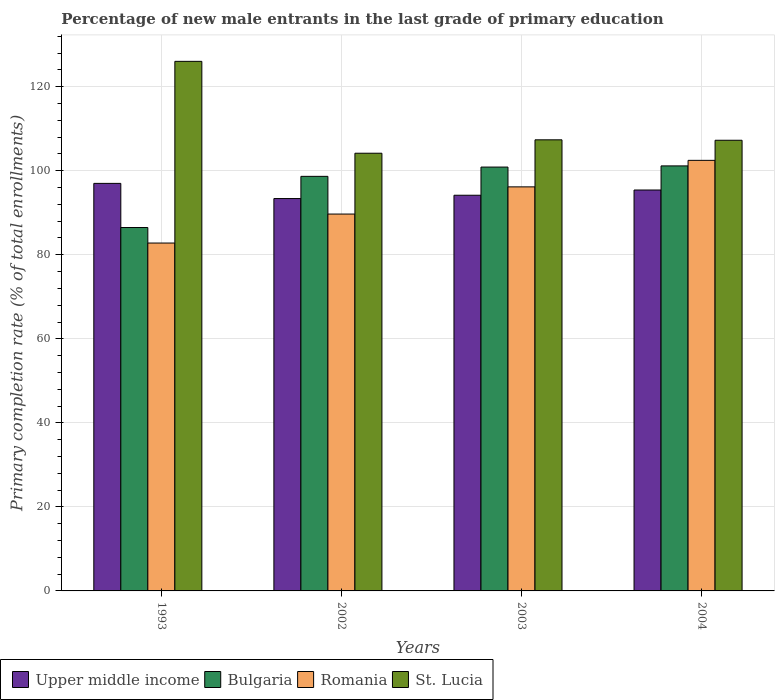How many different coloured bars are there?
Keep it short and to the point. 4. How many groups of bars are there?
Offer a terse response. 4. What is the label of the 2nd group of bars from the left?
Provide a succinct answer. 2002. What is the percentage of new male entrants in Bulgaria in 2003?
Offer a terse response. 100.88. Across all years, what is the maximum percentage of new male entrants in St. Lucia?
Give a very brief answer. 126.04. Across all years, what is the minimum percentage of new male entrants in Bulgaria?
Provide a succinct answer. 86.49. In which year was the percentage of new male entrants in Romania minimum?
Give a very brief answer. 1993. What is the total percentage of new male entrants in St. Lucia in the graph?
Your response must be concise. 444.83. What is the difference between the percentage of new male entrants in Bulgaria in 2002 and that in 2003?
Make the answer very short. -2.21. What is the difference between the percentage of new male entrants in Bulgaria in 1993 and the percentage of new male entrants in Romania in 2002?
Offer a terse response. -3.21. What is the average percentage of new male entrants in St. Lucia per year?
Make the answer very short. 111.21. In the year 2003, what is the difference between the percentage of new male entrants in Bulgaria and percentage of new male entrants in Romania?
Offer a very short reply. 4.71. In how many years, is the percentage of new male entrants in Upper middle income greater than 56 %?
Your answer should be compact. 4. What is the ratio of the percentage of new male entrants in Bulgaria in 2003 to that in 2004?
Ensure brevity in your answer.  1. Is the difference between the percentage of new male entrants in Bulgaria in 1993 and 2004 greater than the difference between the percentage of new male entrants in Romania in 1993 and 2004?
Provide a short and direct response. Yes. What is the difference between the highest and the second highest percentage of new male entrants in Bulgaria?
Offer a terse response. 0.28. What is the difference between the highest and the lowest percentage of new male entrants in Romania?
Provide a succinct answer. 19.68. Is the sum of the percentage of new male entrants in Romania in 1993 and 2004 greater than the maximum percentage of new male entrants in Upper middle income across all years?
Provide a succinct answer. Yes. Is it the case that in every year, the sum of the percentage of new male entrants in St. Lucia and percentage of new male entrants in Bulgaria is greater than the sum of percentage of new male entrants in Upper middle income and percentage of new male entrants in Romania?
Make the answer very short. Yes. What does the 4th bar from the left in 2002 represents?
Offer a terse response. St. Lucia. What does the 1st bar from the right in 2003 represents?
Your answer should be compact. St. Lucia. Are all the bars in the graph horizontal?
Provide a succinct answer. No. How many years are there in the graph?
Provide a short and direct response. 4. What is the difference between two consecutive major ticks on the Y-axis?
Offer a very short reply. 20. Are the values on the major ticks of Y-axis written in scientific E-notation?
Give a very brief answer. No. Does the graph contain any zero values?
Your answer should be compact. No. How are the legend labels stacked?
Your response must be concise. Horizontal. What is the title of the graph?
Your answer should be very brief. Percentage of new male entrants in the last grade of primary education. Does "Ethiopia" appear as one of the legend labels in the graph?
Your response must be concise. No. What is the label or title of the Y-axis?
Make the answer very short. Primary completion rate (% of total enrollments). What is the Primary completion rate (% of total enrollments) of Upper middle income in 1993?
Keep it short and to the point. 96.99. What is the Primary completion rate (% of total enrollments) in Bulgaria in 1993?
Offer a terse response. 86.49. What is the Primary completion rate (% of total enrollments) in Romania in 1993?
Offer a very short reply. 82.8. What is the Primary completion rate (% of total enrollments) in St. Lucia in 1993?
Give a very brief answer. 126.04. What is the Primary completion rate (% of total enrollments) in Upper middle income in 2002?
Your answer should be compact. 93.38. What is the Primary completion rate (% of total enrollments) of Bulgaria in 2002?
Make the answer very short. 98.67. What is the Primary completion rate (% of total enrollments) of Romania in 2002?
Ensure brevity in your answer.  89.69. What is the Primary completion rate (% of total enrollments) in St. Lucia in 2002?
Make the answer very short. 104.17. What is the Primary completion rate (% of total enrollments) of Upper middle income in 2003?
Give a very brief answer. 94.17. What is the Primary completion rate (% of total enrollments) of Bulgaria in 2003?
Keep it short and to the point. 100.88. What is the Primary completion rate (% of total enrollments) in Romania in 2003?
Give a very brief answer. 96.16. What is the Primary completion rate (% of total enrollments) in St. Lucia in 2003?
Offer a terse response. 107.36. What is the Primary completion rate (% of total enrollments) of Upper middle income in 2004?
Your answer should be compact. 95.42. What is the Primary completion rate (% of total enrollments) in Bulgaria in 2004?
Offer a terse response. 101.16. What is the Primary completion rate (% of total enrollments) of Romania in 2004?
Make the answer very short. 102.48. What is the Primary completion rate (% of total enrollments) in St. Lucia in 2004?
Your response must be concise. 107.26. Across all years, what is the maximum Primary completion rate (% of total enrollments) of Upper middle income?
Make the answer very short. 96.99. Across all years, what is the maximum Primary completion rate (% of total enrollments) of Bulgaria?
Offer a very short reply. 101.16. Across all years, what is the maximum Primary completion rate (% of total enrollments) of Romania?
Provide a succinct answer. 102.48. Across all years, what is the maximum Primary completion rate (% of total enrollments) of St. Lucia?
Your answer should be compact. 126.04. Across all years, what is the minimum Primary completion rate (% of total enrollments) in Upper middle income?
Your answer should be compact. 93.38. Across all years, what is the minimum Primary completion rate (% of total enrollments) in Bulgaria?
Keep it short and to the point. 86.49. Across all years, what is the minimum Primary completion rate (% of total enrollments) of Romania?
Give a very brief answer. 82.8. Across all years, what is the minimum Primary completion rate (% of total enrollments) in St. Lucia?
Give a very brief answer. 104.17. What is the total Primary completion rate (% of total enrollments) in Upper middle income in the graph?
Your answer should be very brief. 379.97. What is the total Primary completion rate (% of total enrollments) in Bulgaria in the graph?
Offer a terse response. 387.19. What is the total Primary completion rate (% of total enrollments) of Romania in the graph?
Ensure brevity in your answer.  371.13. What is the total Primary completion rate (% of total enrollments) in St. Lucia in the graph?
Your answer should be very brief. 444.83. What is the difference between the Primary completion rate (% of total enrollments) in Upper middle income in 1993 and that in 2002?
Provide a short and direct response. 3.61. What is the difference between the Primary completion rate (% of total enrollments) of Bulgaria in 1993 and that in 2002?
Your answer should be very brief. -12.18. What is the difference between the Primary completion rate (% of total enrollments) of Romania in 1993 and that in 2002?
Offer a terse response. -6.9. What is the difference between the Primary completion rate (% of total enrollments) in St. Lucia in 1993 and that in 2002?
Make the answer very short. 21.86. What is the difference between the Primary completion rate (% of total enrollments) of Upper middle income in 1993 and that in 2003?
Provide a short and direct response. 2.82. What is the difference between the Primary completion rate (% of total enrollments) in Bulgaria in 1993 and that in 2003?
Your response must be concise. -14.39. What is the difference between the Primary completion rate (% of total enrollments) in Romania in 1993 and that in 2003?
Provide a succinct answer. -13.37. What is the difference between the Primary completion rate (% of total enrollments) of St. Lucia in 1993 and that in 2003?
Provide a succinct answer. 18.68. What is the difference between the Primary completion rate (% of total enrollments) of Upper middle income in 1993 and that in 2004?
Offer a very short reply. 1.57. What is the difference between the Primary completion rate (% of total enrollments) of Bulgaria in 1993 and that in 2004?
Provide a short and direct response. -14.67. What is the difference between the Primary completion rate (% of total enrollments) in Romania in 1993 and that in 2004?
Ensure brevity in your answer.  -19.68. What is the difference between the Primary completion rate (% of total enrollments) of St. Lucia in 1993 and that in 2004?
Provide a short and direct response. 18.78. What is the difference between the Primary completion rate (% of total enrollments) of Upper middle income in 2002 and that in 2003?
Make the answer very short. -0.79. What is the difference between the Primary completion rate (% of total enrollments) in Bulgaria in 2002 and that in 2003?
Provide a short and direct response. -2.21. What is the difference between the Primary completion rate (% of total enrollments) in Romania in 2002 and that in 2003?
Offer a terse response. -6.47. What is the difference between the Primary completion rate (% of total enrollments) in St. Lucia in 2002 and that in 2003?
Provide a short and direct response. -3.19. What is the difference between the Primary completion rate (% of total enrollments) in Upper middle income in 2002 and that in 2004?
Provide a short and direct response. -2.04. What is the difference between the Primary completion rate (% of total enrollments) in Bulgaria in 2002 and that in 2004?
Provide a succinct answer. -2.49. What is the difference between the Primary completion rate (% of total enrollments) in Romania in 2002 and that in 2004?
Offer a terse response. -12.78. What is the difference between the Primary completion rate (% of total enrollments) in St. Lucia in 2002 and that in 2004?
Give a very brief answer. -3.08. What is the difference between the Primary completion rate (% of total enrollments) of Upper middle income in 2003 and that in 2004?
Ensure brevity in your answer.  -1.25. What is the difference between the Primary completion rate (% of total enrollments) of Bulgaria in 2003 and that in 2004?
Keep it short and to the point. -0.28. What is the difference between the Primary completion rate (% of total enrollments) of Romania in 2003 and that in 2004?
Give a very brief answer. -6.31. What is the difference between the Primary completion rate (% of total enrollments) in St. Lucia in 2003 and that in 2004?
Offer a terse response. 0.11. What is the difference between the Primary completion rate (% of total enrollments) in Upper middle income in 1993 and the Primary completion rate (% of total enrollments) in Bulgaria in 2002?
Make the answer very short. -1.68. What is the difference between the Primary completion rate (% of total enrollments) in Upper middle income in 1993 and the Primary completion rate (% of total enrollments) in Romania in 2002?
Provide a succinct answer. 7.3. What is the difference between the Primary completion rate (% of total enrollments) in Upper middle income in 1993 and the Primary completion rate (% of total enrollments) in St. Lucia in 2002?
Offer a terse response. -7.18. What is the difference between the Primary completion rate (% of total enrollments) in Bulgaria in 1993 and the Primary completion rate (% of total enrollments) in Romania in 2002?
Offer a very short reply. -3.21. What is the difference between the Primary completion rate (% of total enrollments) in Bulgaria in 1993 and the Primary completion rate (% of total enrollments) in St. Lucia in 2002?
Your answer should be compact. -17.69. What is the difference between the Primary completion rate (% of total enrollments) in Romania in 1993 and the Primary completion rate (% of total enrollments) in St. Lucia in 2002?
Provide a succinct answer. -21.38. What is the difference between the Primary completion rate (% of total enrollments) in Upper middle income in 1993 and the Primary completion rate (% of total enrollments) in Bulgaria in 2003?
Offer a very short reply. -3.88. What is the difference between the Primary completion rate (% of total enrollments) in Upper middle income in 1993 and the Primary completion rate (% of total enrollments) in Romania in 2003?
Offer a terse response. 0.83. What is the difference between the Primary completion rate (% of total enrollments) in Upper middle income in 1993 and the Primary completion rate (% of total enrollments) in St. Lucia in 2003?
Your answer should be very brief. -10.37. What is the difference between the Primary completion rate (% of total enrollments) of Bulgaria in 1993 and the Primary completion rate (% of total enrollments) of Romania in 2003?
Your answer should be very brief. -9.68. What is the difference between the Primary completion rate (% of total enrollments) in Bulgaria in 1993 and the Primary completion rate (% of total enrollments) in St. Lucia in 2003?
Provide a succinct answer. -20.87. What is the difference between the Primary completion rate (% of total enrollments) in Romania in 1993 and the Primary completion rate (% of total enrollments) in St. Lucia in 2003?
Provide a succinct answer. -24.57. What is the difference between the Primary completion rate (% of total enrollments) in Upper middle income in 1993 and the Primary completion rate (% of total enrollments) in Bulgaria in 2004?
Offer a terse response. -4.16. What is the difference between the Primary completion rate (% of total enrollments) in Upper middle income in 1993 and the Primary completion rate (% of total enrollments) in Romania in 2004?
Your answer should be compact. -5.48. What is the difference between the Primary completion rate (% of total enrollments) in Upper middle income in 1993 and the Primary completion rate (% of total enrollments) in St. Lucia in 2004?
Provide a short and direct response. -10.26. What is the difference between the Primary completion rate (% of total enrollments) of Bulgaria in 1993 and the Primary completion rate (% of total enrollments) of Romania in 2004?
Offer a very short reply. -15.99. What is the difference between the Primary completion rate (% of total enrollments) in Bulgaria in 1993 and the Primary completion rate (% of total enrollments) in St. Lucia in 2004?
Your answer should be very brief. -20.77. What is the difference between the Primary completion rate (% of total enrollments) of Romania in 1993 and the Primary completion rate (% of total enrollments) of St. Lucia in 2004?
Make the answer very short. -24.46. What is the difference between the Primary completion rate (% of total enrollments) in Upper middle income in 2002 and the Primary completion rate (% of total enrollments) in Bulgaria in 2003?
Make the answer very short. -7.49. What is the difference between the Primary completion rate (% of total enrollments) of Upper middle income in 2002 and the Primary completion rate (% of total enrollments) of Romania in 2003?
Provide a short and direct response. -2.78. What is the difference between the Primary completion rate (% of total enrollments) of Upper middle income in 2002 and the Primary completion rate (% of total enrollments) of St. Lucia in 2003?
Ensure brevity in your answer.  -13.98. What is the difference between the Primary completion rate (% of total enrollments) of Bulgaria in 2002 and the Primary completion rate (% of total enrollments) of Romania in 2003?
Provide a short and direct response. 2.5. What is the difference between the Primary completion rate (% of total enrollments) of Bulgaria in 2002 and the Primary completion rate (% of total enrollments) of St. Lucia in 2003?
Offer a terse response. -8.69. What is the difference between the Primary completion rate (% of total enrollments) in Romania in 2002 and the Primary completion rate (% of total enrollments) in St. Lucia in 2003?
Your answer should be compact. -17.67. What is the difference between the Primary completion rate (% of total enrollments) of Upper middle income in 2002 and the Primary completion rate (% of total enrollments) of Bulgaria in 2004?
Offer a terse response. -7.77. What is the difference between the Primary completion rate (% of total enrollments) of Upper middle income in 2002 and the Primary completion rate (% of total enrollments) of Romania in 2004?
Give a very brief answer. -9.1. What is the difference between the Primary completion rate (% of total enrollments) of Upper middle income in 2002 and the Primary completion rate (% of total enrollments) of St. Lucia in 2004?
Your answer should be very brief. -13.87. What is the difference between the Primary completion rate (% of total enrollments) in Bulgaria in 2002 and the Primary completion rate (% of total enrollments) in Romania in 2004?
Your answer should be compact. -3.81. What is the difference between the Primary completion rate (% of total enrollments) of Bulgaria in 2002 and the Primary completion rate (% of total enrollments) of St. Lucia in 2004?
Offer a terse response. -8.59. What is the difference between the Primary completion rate (% of total enrollments) of Romania in 2002 and the Primary completion rate (% of total enrollments) of St. Lucia in 2004?
Ensure brevity in your answer.  -17.56. What is the difference between the Primary completion rate (% of total enrollments) in Upper middle income in 2003 and the Primary completion rate (% of total enrollments) in Bulgaria in 2004?
Offer a terse response. -6.98. What is the difference between the Primary completion rate (% of total enrollments) in Upper middle income in 2003 and the Primary completion rate (% of total enrollments) in Romania in 2004?
Keep it short and to the point. -8.31. What is the difference between the Primary completion rate (% of total enrollments) of Upper middle income in 2003 and the Primary completion rate (% of total enrollments) of St. Lucia in 2004?
Make the answer very short. -13.08. What is the difference between the Primary completion rate (% of total enrollments) in Bulgaria in 2003 and the Primary completion rate (% of total enrollments) in Romania in 2004?
Offer a very short reply. -1.6. What is the difference between the Primary completion rate (% of total enrollments) in Bulgaria in 2003 and the Primary completion rate (% of total enrollments) in St. Lucia in 2004?
Ensure brevity in your answer.  -6.38. What is the difference between the Primary completion rate (% of total enrollments) in Romania in 2003 and the Primary completion rate (% of total enrollments) in St. Lucia in 2004?
Make the answer very short. -11.09. What is the average Primary completion rate (% of total enrollments) in Upper middle income per year?
Offer a very short reply. 94.99. What is the average Primary completion rate (% of total enrollments) in Bulgaria per year?
Your answer should be very brief. 96.8. What is the average Primary completion rate (% of total enrollments) of Romania per year?
Your response must be concise. 92.78. What is the average Primary completion rate (% of total enrollments) in St. Lucia per year?
Provide a short and direct response. 111.21. In the year 1993, what is the difference between the Primary completion rate (% of total enrollments) in Upper middle income and Primary completion rate (% of total enrollments) in Bulgaria?
Offer a terse response. 10.51. In the year 1993, what is the difference between the Primary completion rate (% of total enrollments) in Upper middle income and Primary completion rate (% of total enrollments) in Romania?
Your answer should be compact. 14.2. In the year 1993, what is the difference between the Primary completion rate (% of total enrollments) in Upper middle income and Primary completion rate (% of total enrollments) in St. Lucia?
Offer a very short reply. -29.04. In the year 1993, what is the difference between the Primary completion rate (% of total enrollments) of Bulgaria and Primary completion rate (% of total enrollments) of Romania?
Provide a short and direct response. 3.69. In the year 1993, what is the difference between the Primary completion rate (% of total enrollments) of Bulgaria and Primary completion rate (% of total enrollments) of St. Lucia?
Ensure brevity in your answer.  -39.55. In the year 1993, what is the difference between the Primary completion rate (% of total enrollments) of Romania and Primary completion rate (% of total enrollments) of St. Lucia?
Give a very brief answer. -43.24. In the year 2002, what is the difference between the Primary completion rate (% of total enrollments) in Upper middle income and Primary completion rate (% of total enrollments) in Bulgaria?
Offer a very short reply. -5.29. In the year 2002, what is the difference between the Primary completion rate (% of total enrollments) of Upper middle income and Primary completion rate (% of total enrollments) of Romania?
Offer a very short reply. 3.69. In the year 2002, what is the difference between the Primary completion rate (% of total enrollments) of Upper middle income and Primary completion rate (% of total enrollments) of St. Lucia?
Offer a terse response. -10.79. In the year 2002, what is the difference between the Primary completion rate (% of total enrollments) of Bulgaria and Primary completion rate (% of total enrollments) of Romania?
Make the answer very short. 8.97. In the year 2002, what is the difference between the Primary completion rate (% of total enrollments) in Bulgaria and Primary completion rate (% of total enrollments) in St. Lucia?
Keep it short and to the point. -5.5. In the year 2002, what is the difference between the Primary completion rate (% of total enrollments) in Romania and Primary completion rate (% of total enrollments) in St. Lucia?
Ensure brevity in your answer.  -14.48. In the year 2003, what is the difference between the Primary completion rate (% of total enrollments) in Upper middle income and Primary completion rate (% of total enrollments) in Bulgaria?
Give a very brief answer. -6.7. In the year 2003, what is the difference between the Primary completion rate (% of total enrollments) of Upper middle income and Primary completion rate (% of total enrollments) of Romania?
Provide a succinct answer. -1.99. In the year 2003, what is the difference between the Primary completion rate (% of total enrollments) of Upper middle income and Primary completion rate (% of total enrollments) of St. Lucia?
Ensure brevity in your answer.  -13.19. In the year 2003, what is the difference between the Primary completion rate (% of total enrollments) in Bulgaria and Primary completion rate (% of total enrollments) in Romania?
Provide a succinct answer. 4.71. In the year 2003, what is the difference between the Primary completion rate (% of total enrollments) in Bulgaria and Primary completion rate (% of total enrollments) in St. Lucia?
Provide a short and direct response. -6.49. In the year 2003, what is the difference between the Primary completion rate (% of total enrollments) of Romania and Primary completion rate (% of total enrollments) of St. Lucia?
Your answer should be very brief. -11.2. In the year 2004, what is the difference between the Primary completion rate (% of total enrollments) of Upper middle income and Primary completion rate (% of total enrollments) of Bulgaria?
Ensure brevity in your answer.  -5.74. In the year 2004, what is the difference between the Primary completion rate (% of total enrollments) in Upper middle income and Primary completion rate (% of total enrollments) in Romania?
Offer a very short reply. -7.06. In the year 2004, what is the difference between the Primary completion rate (% of total enrollments) in Upper middle income and Primary completion rate (% of total enrollments) in St. Lucia?
Your response must be concise. -11.84. In the year 2004, what is the difference between the Primary completion rate (% of total enrollments) in Bulgaria and Primary completion rate (% of total enrollments) in Romania?
Ensure brevity in your answer.  -1.32. In the year 2004, what is the difference between the Primary completion rate (% of total enrollments) in Bulgaria and Primary completion rate (% of total enrollments) in St. Lucia?
Your answer should be very brief. -6.1. In the year 2004, what is the difference between the Primary completion rate (% of total enrollments) in Romania and Primary completion rate (% of total enrollments) in St. Lucia?
Provide a succinct answer. -4.78. What is the ratio of the Primary completion rate (% of total enrollments) in Upper middle income in 1993 to that in 2002?
Offer a very short reply. 1.04. What is the ratio of the Primary completion rate (% of total enrollments) of Bulgaria in 1993 to that in 2002?
Provide a succinct answer. 0.88. What is the ratio of the Primary completion rate (% of total enrollments) of St. Lucia in 1993 to that in 2002?
Offer a very short reply. 1.21. What is the ratio of the Primary completion rate (% of total enrollments) in Upper middle income in 1993 to that in 2003?
Offer a very short reply. 1.03. What is the ratio of the Primary completion rate (% of total enrollments) of Bulgaria in 1993 to that in 2003?
Give a very brief answer. 0.86. What is the ratio of the Primary completion rate (% of total enrollments) in Romania in 1993 to that in 2003?
Offer a very short reply. 0.86. What is the ratio of the Primary completion rate (% of total enrollments) in St. Lucia in 1993 to that in 2003?
Provide a short and direct response. 1.17. What is the ratio of the Primary completion rate (% of total enrollments) in Upper middle income in 1993 to that in 2004?
Provide a succinct answer. 1.02. What is the ratio of the Primary completion rate (% of total enrollments) in Bulgaria in 1993 to that in 2004?
Give a very brief answer. 0.85. What is the ratio of the Primary completion rate (% of total enrollments) of Romania in 1993 to that in 2004?
Keep it short and to the point. 0.81. What is the ratio of the Primary completion rate (% of total enrollments) of St. Lucia in 1993 to that in 2004?
Make the answer very short. 1.18. What is the ratio of the Primary completion rate (% of total enrollments) of Bulgaria in 2002 to that in 2003?
Your answer should be very brief. 0.98. What is the ratio of the Primary completion rate (% of total enrollments) in Romania in 2002 to that in 2003?
Keep it short and to the point. 0.93. What is the ratio of the Primary completion rate (% of total enrollments) in St. Lucia in 2002 to that in 2003?
Your answer should be compact. 0.97. What is the ratio of the Primary completion rate (% of total enrollments) in Upper middle income in 2002 to that in 2004?
Keep it short and to the point. 0.98. What is the ratio of the Primary completion rate (% of total enrollments) of Bulgaria in 2002 to that in 2004?
Your answer should be compact. 0.98. What is the ratio of the Primary completion rate (% of total enrollments) of Romania in 2002 to that in 2004?
Your answer should be compact. 0.88. What is the ratio of the Primary completion rate (% of total enrollments) in St. Lucia in 2002 to that in 2004?
Keep it short and to the point. 0.97. What is the ratio of the Primary completion rate (% of total enrollments) of Upper middle income in 2003 to that in 2004?
Make the answer very short. 0.99. What is the ratio of the Primary completion rate (% of total enrollments) of Bulgaria in 2003 to that in 2004?
Your response must be concise. 1. What is the ratio of the Primary completion rate (% of total enrollments) in Romania in 2003 to that in 2004?
Make the answer very short. 0.94. What is the difference between the highest and the second highest Primary completion rate (% of total enrollments) in Upper middle income?
Provide a succinct answer. 1.57. What is the difference between the highest and the second highest Primary completion rate (% of total enrollments) in Bulgaria?
Your answer should be compact. 0.28. What is the difference between the highest and the second highest Primary completion rate (% of total enrollments) of Romania?
Your answer should be compact. 6.31. What is the difference between the highest and the second highest Primary completion rate (% of total enrollments) in St. Lucia?
Offer a very short reply. 18.68. What is the difference between the highest and the lowest Primary completion rate (% of total enrollments) of Upper middle income?
Give a very brief answer. 3.61. What is the difference between the highest and the lowest Primary completion rate (% of total enrollments) of Bulgaria?
Ensure brevity in your answer.  14.67. What is the difference between the highest and the lowest Primary completion rate (% of total enrollments) of Romania?
Offer a terse response. 19.68. What is the difference between the highest and the lowest Primary completion rate (% of total enrollments) in St. Lucia?
Provide a short and direct response. 21.86. 